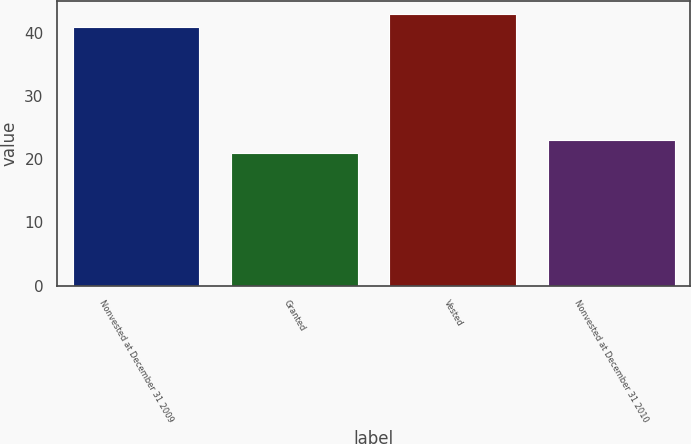Convert chart to OTSL. <chart><loc_0><loc_0><loc_500><loc_500><bar_chart><fcel>Nonvested at December 31 2009<fcel>Granted<fcel>Vested<fcel>Nonvested at December 31 2010<nl><fcel>41<fcel>21<fcel>43<fcel>23<nl></chart> 